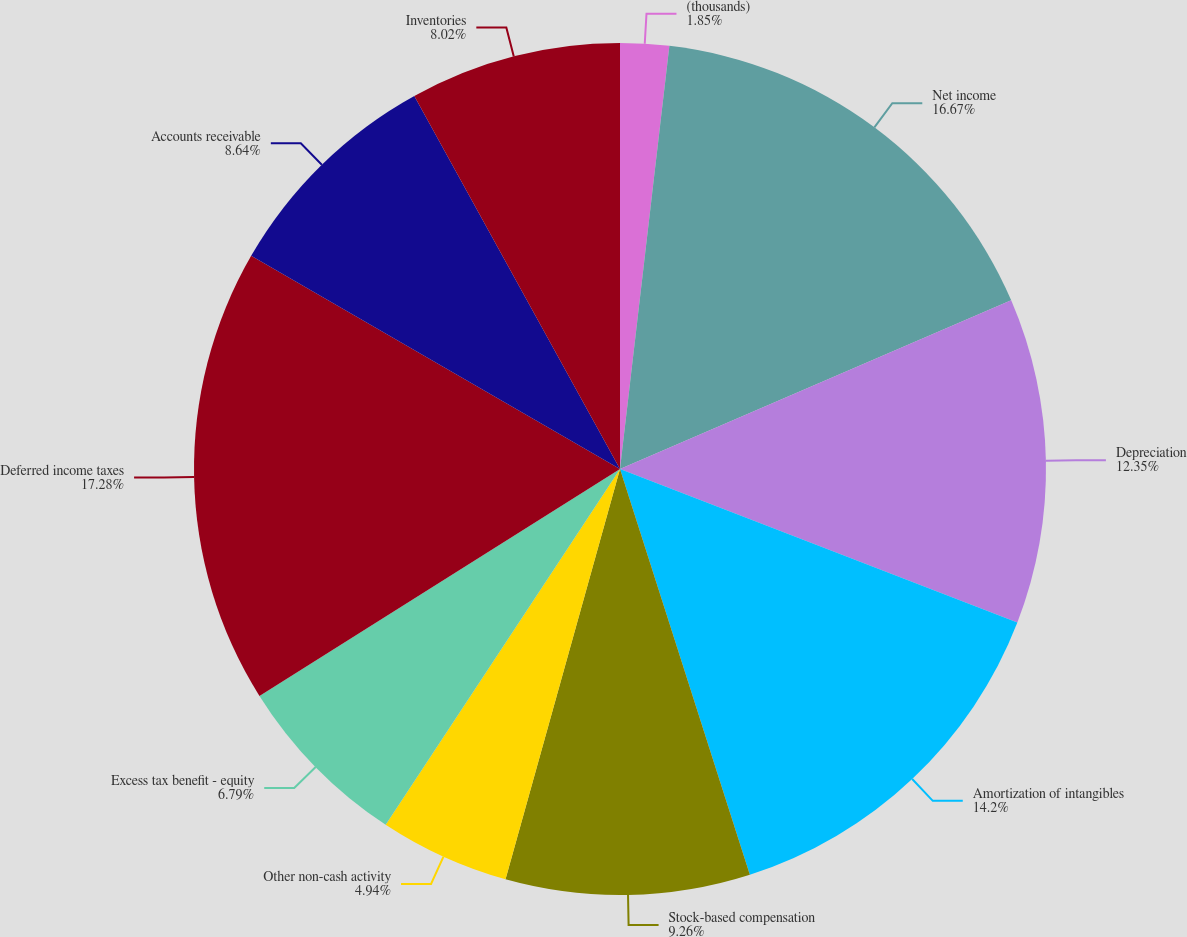Convert chart to OTSL. <chart><loc_0><loc_0><loc_500><loc_500><pie_chart><fcel>(thousands)<fcel>Net income<fcel>Depreciation<fcel>Amortization of intangibles<fcel>Stock-based compensation<fcel>Other non-cash activity<fcel>Excess tax benefit - equity<fcel>Deferred income taxes<fcel>Accounts receivable<fcel>Inventories<nl><fcel>1.85%<fcel>16.67%<fcel>12.35%<fcel>14.2%<fcel>9.26%<fcel>4.94%<fcel>6.79%<fcel>17.28%<fcel>8.64%<fcel>8.02%<nl></chart> 